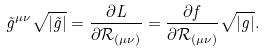<formula> <loc_0><loc_0><loc_500><loc_500>\tilde { g } ^ { \mu \nu } \sqrt { | \tilde { g } | } = \frac { \partial L } { \partial \mathcal { R } _ { ( \mu \nu ) } } = \frac { \partial f } { \partial \mathcal { R _ { ( \mu \nu ) } } } \sqrt { | g | } .</formula> 